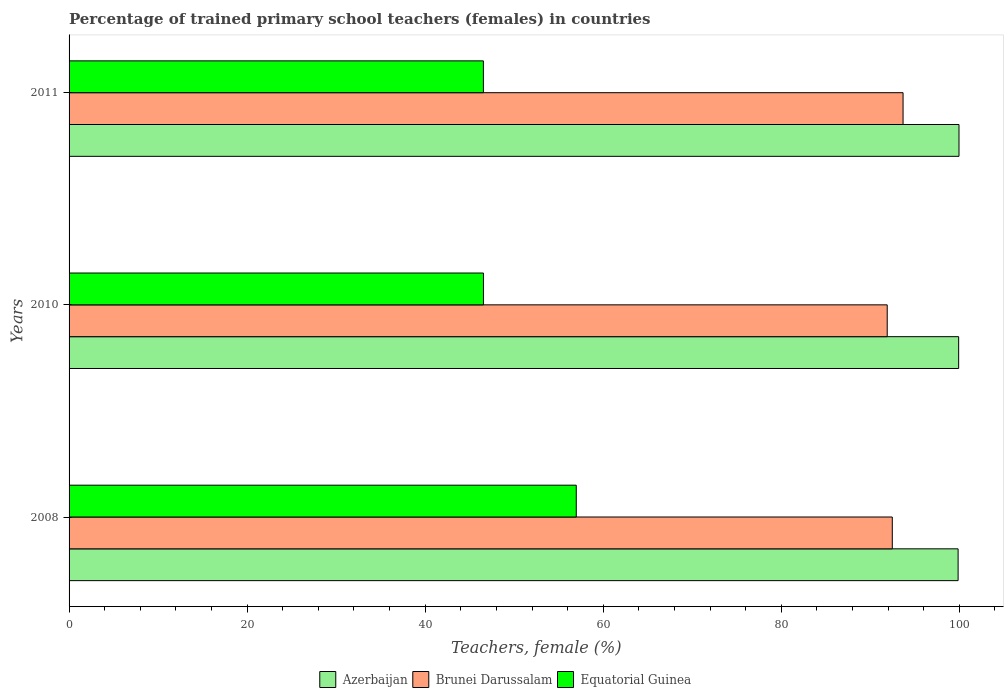How many groups of bars are there?
Your answer should be compact. 3. How many bars are there on the 3rd tick from the bottom?
Ensure brevity in your answer.  3. What is the label of the 1st group of bars from the top?
Your answer should be very brief. 2011. What is the percentage of trained primary school teachers (females) in Azerbaijan in 2010?
Provide a short and direct response. 99.92. Across all years, what is the maximum percentage of trained primary school teachers (females) in Azerbaijan?
Your response must be concise. 99.96. Across all years, what is the minimum percentage of trained primary school teachers (females) in Equatorial Guinea?
Give a very brief answer. 46.54. What is the total percentage of trained primary school teachers (females) in Brunei Darussalam in the graph?
Your answer should be compact. 278.04. What is the difference between the percentage of trained primary school teachers (females) in Brunei Darussalam in 2008 and that in 2011?
Give a very brief answer. -1.21. What is the difference between the percentage of trained primary school teachers (females) in Azerbaijan in 2010 and the percentage of trained primary school teachers (females) in Brunei Darussalam in 2011?
Your answer should be compact. 6.24. What is the average percentage of trained primary school teachers (females) in Equatorial Guinea per year?
Provide a short and direct response. 50.02. In the year 2008, what is the difference between the percentage of trained primary school teachers (females) in Azerbaijan and percentage of trained primary school teachers (females) in Equatorial Guinea?
Your response must be concise. 42.89. In how many years, is the percentage of trained primary school teachers (females) in Brunei Darussalam greater than 44 %?
Your answer should be compact. 3. What is the ratio of the percentage of trained primary school teachers (females) in Azerbaijan in 2008 to that in 2010?
Offer a very short reply. 1. What is the difference between the highest and the second highest percentage of trained primary school teachers (females) in Brunei Darussalam?
Keep it short and to the point. 1.21. What is the difference between the highest and the lowest percentage of trained primary school teachers (females) in Azerbaijan?
Provide a short and direct response. 0.1. In how many years, is the percentage of trained primary school teachers (females) in Azerbaijan greater than the average percentage of trained primary school teachers (females) in Azerbaijan taken over all years?
Offer a very short reply. 2. What does the 3rd bar from the top in 2010 represents?
Your response must be concise. Azerbaijan. What does the 1st bar from the bottom in 2010 represents?
Make the answer very short. Azerbaijan. Is it the case that in every year, the sum of the percentage of trained primary school teachers (females) in Brunei Darussalam and percentage of trained primary school teachers (females) in Azerbaijan is greater than the percentage of trained primary school teachers (females) in Equatorial Guinea?
Give a very brief answer. Yes. Are all the bars in the graph horizontal?
Make the answer very short. Yes. How many years are there in the graph?
Your answer should be very brief. 3. Are the values on the major ticks of X-axis written in scientific E-notation?
Make the answer very short. No. Does the graph contain any zero values?
Offer a terse response. No. Where does the legend appear in the graph?
Keep it short and to the point. Bottom center. How many legend labels are there?
Give a very brief answer. 3. How are the legend labels stacked?
Your answer should be very brief. Horizontal. What is the title of the graph?
Keep it short and to the point. Percentage of trained primary school teachers (females) in countries. What is the label or title of the X-axis?
Provide a succinct answer. Teachers, female (%). What is the Teachers, female (%) in Azerbaijan in 2008?
Keep it short and to the point. 99.86. What is the Teachers, female (%) in Brunei Darussalam in 2008?
Offer a terse response. 92.47. What is the Teachers, female (%) of Equatorial Guinea in 2008?
Make the answer very short. 56.97. What is the Teachers, female (%) of Azerbaijan in 2010?
Provide a short and direct response. 99.92. What is the Teachers, female (%) of Brunei Darussalam in 2010?
Give a very brief answer. 91.9. What is the Teachers, female (%) of Equatorial Guinea in 2010?
Your answer should be very brief. 46.54. What is the Teachers, female (%) in Azerbaijan in 2011?
Provide a succinct answer. 99.96. What is the Teachers, female (%) of Brunei Darussalam in 2011?
Provide a succinct answer. 93.68. What is the Teachers, female (%) of Equatorial Guinea in 2011?
Ensure brevity in your answer.  46.54. Across all years, what is the maximum Teachers, female (%) of Azerbaijan?
Make the answer very short. 99.96. Across all years, what is the maximum Teachers, female (%) of Brunei Darussalam?
Provide a succinct answer. 93.68. Across all years, what is the maximum Teachers, female (%) in Equatorial Guinea?
Offer a very short reply. 56.97. Across all years, what is the minimum Teachers, female (%) in Azerbaijan?
Provide a short and direct response. 99.86. Across all years, what is the minimum Teachers, female (%) in Brunei Darussalam?
Give a very brief answer. 91.9. Across all years, what is the minimum Teachers, female (%) of Equatorial Guinea?
Provide a short and direct response. 46.54. What is the total Teachers, female (%) in Azerbaijan in the graph?
Provide a short and direct response. 299.74. What is the total Teachers, female (%) of Brunei Darussalam in the graph?
Offer a very short reply. 278.04. What is the total Teachers, female (%) of Equatorial Guinea in the graph?
Your response must be concise. 150.05. What is the difference between the Teachers, female (%) in Azerbaijan in 2008 and that in 2010?
Your answer should be very brief. -0.06. What is the difference between the Teachers, female (%) in Brunei Darussalam in 2008 and that in 2010?
Offer a very short reply. 0.57. What is the difference between the Teachers, female (%) in Equatorial Guinea in 2008 and that in 2010?
Make the answer very short. 10.43. What is the difference between the Teachers, female (%) of Azerbaijan in 2008 and that in 2011?
Your answer should be compact. -0.1. What is the difference between the Teachers, female (%) of Brunei Darussalam in 2008 and that in 2011?
Offer a very short reply. -1.21. What is the difference between the Teachers, female (%) of Equatorial Guinea in 2008 and that in 2011?
Ensure brevity in your answer.  10.43. What is the difference between the Teachers, female (%) of Azerbaijan in 2010 and that in 2011?
Make the answer very short. -0.04. What is the difference between the Teachers, female (%) of Brunei Darussalam in 2010 and that in 2011?
Provide a short and direct response. -1.78. What is the difference between the Teachers, female (%) in Equatorial Guinea in 2010 and that in 2011?
Your answer should be compact. 0.01. What is the difference between the Teachers, female (%) of Azerbaijan in 2008 and the Teachers, female (%) of Brunei Darussalam in 2010?
Your answer should be very brief. 7.96. What is the difference between the Teachers, female (%) in Azerbaijan in 2008 and the Teachers, female (%) in Equatorial Guinea in 2010?
Ensure brevity in your answer.  53.32. What is the difference between the Teachers, female (%) of Brunei Darussalam in 2008 and the Teachers, female (%) of Equatorial Guinea in 2010?
Ensure brevity in your answer.  45.92. What is the difference between the Teachers, female (%) of Azerbaijan in 2008 and the Teachers, female (%) of Brunei Darussalam in 2011?
Offer a terse response. 6.18. What is the difference between the Teachers, female (%) of Azerbaijan in 2008 and the Teachers, female (%) of Equatorial Guinea in 2011?
Keep it short and to the point. 53.32. What is the difference between the Teachers, female (%) in Brunei Darussalam in 2008 and the Teachers, female (%) in Equatorial Guinea in 2011?
Your answer should be very brief. 45.93. What is the difference between the Teachers, female (%) in Azerbaijan in 2010 and the Teachers, female (%) in Brunei Darussalam in 2011?
Ensure brevity in your answer.  6.24. What is the difference between the Teachers, female (%) of Azerbaijan in 2010 and the Teachers, female (%) of Equatorial Guinea in 2011?
Make the answer very short. 53.38. What is the difference between the Teachers, female (%) in Brunei Darussalam in 2010 and the Teachers, female (%) in Equatorial Guinea in 2011?
Your response must be concise. 45.36. What is the average Teachers, female (%) in Azerbaijan per year?
Give a very brief answer. 99.91. What is the average Teachers, female (%) in Brunei Darussalam per year?
Your response must be concise. 92.68. What is the average Teachers, female (%) of Equatorial Guinea per year?
Provide a short and direct response. 50.02. In the year 2008, what is the difference between the Teachers, female (%) of Azerbaijan and Teachers, female (%) of Brunei Darussalam?
Keep it short and to the point. 7.39. In the year 2008, what is the difference between the Teachers, female (%) in Azerbaijan and Teachers, female (%) in Equatorial Guinea?
Your answer should be compact. 42.89. In the year 2008, what is the difference between the Teachers, female (%) in Brunei Darussalam and Teachers, female (%) in Equatorial Guinea?
Your answer should be very brief. 35.5. In the year 2010, what is the difference between the Teachers, female (%) of Azerbaijan and Teachers, female (%) of Brunei Darussalam?
Your answer should be very brief. 8.02. In the year 2010, what is the difference between the Teachers, female (%) of Azerbaijan and Teachers, female (%) of Equatorial Guinea?
Your response must be concise. 53.38. In the year 2010, what is the difference between the Teachers, female (%) in Brunei Darussalam and Teachers, female (%) in Equatorial Guinea?
Make the answer very short. 45.35. In the year 2011, what is the difference between the Teachers, female (%) in Azerbaijan and Teachers, female (%) in Brunei Darussalam?
Offer a very short reply. 6.28. In the year 2011, what is the difference between the Teachers, female (%) in Azerbaijan and Teachers, female (%) in Equatorial Guinea?
Provide a short and direct response. 53.42. In the year 2011, what is the difference between the Teachers, female (%) in Brunei Darussalam and Teachers, female (%) in Equatorial Guinea?
Offer a terse response. 47.14. What is the ratio of the Teachers, female (%) in Azerbaijan in 2008 to that in 2010?
Make the answer very short. 1. What is the ratio of the Teachers, female (%) of Brunei Darussalam in 2008 to that in 2010?
Provide a short and direct response. 1.01. What is the ratio of the Teachers, female (%) of Equatorial Guinea in 2008 to that in 2010?
Offer a very short reply. 1.22. What is the ratio of the Teachers, female (%) in Brunei Darussalam in 2008 to that in 2011?
Your answer should be compact. 0.99. What is the ratio of the Teachers, female (%) of Equatorial Guinea in 2008 to that in 2011?
Your answer should be very brief. 1.22. What is the ratio of the Teachers, female (%) of Azerbaijan in 2010 to that in 2011?
Make the answer very short. 1. What is the difference between the highest and the second highest Teachers, female (%) of Azerbaijan?
Offer a very short reply. 0.04. What is the difference between the highest and the second highest Teachers, female (%) of Brunei Darussalam?
Your response must be concise. 1.21. What is the difference between the highest and the second highest Teachers, female (%) of Equatorial Guinea?
Provide a short and direct response. 10.43. What is the difference between the highest and the lowest Teachers, female (%) in Azerbaijan?
Keep it short and to the point. 0.1. What is the difference between the highest and the lowest Teachers, female (%) in Brunei Darussalam?
Your answer should be very brief. 1.78. What is the difference between the highest and the lowest Teachers, female (%) of Equatorial Guinea?
Offer a very short reply. 10.43. 